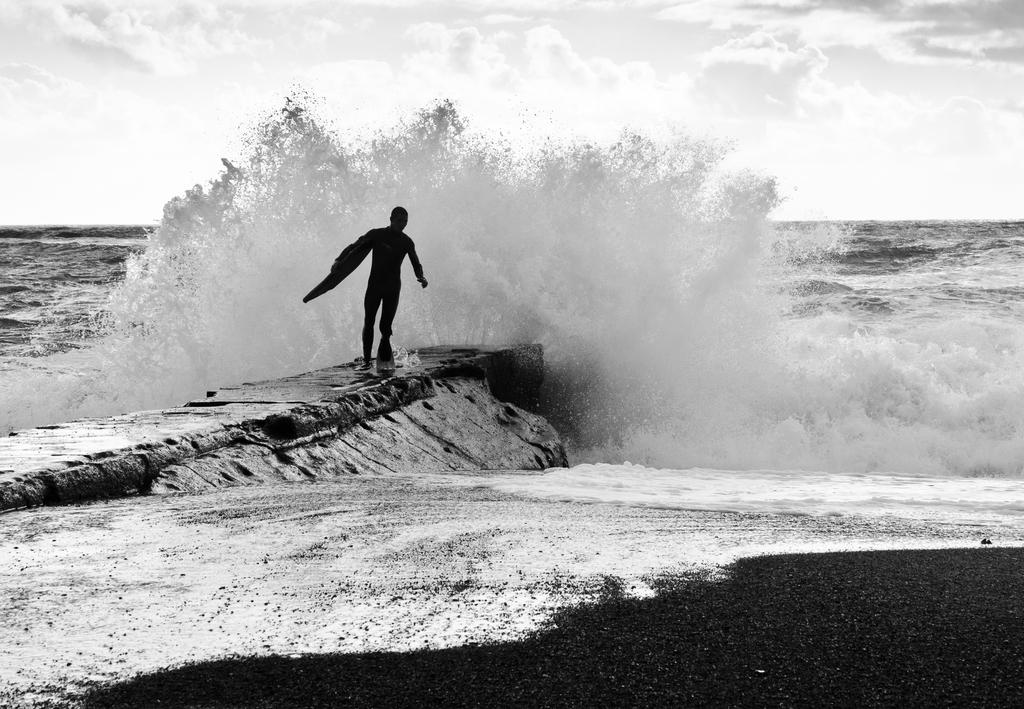What can be seen in the image? There is a person in the image. What is the person holding in the image? The person is holding an object. What can be seen in the distance in the image? There is an ocean visible in the background of the image. What type of pin can be seen on the person's shirt in the image? There is no pin visible on the person's shirt in the image. 